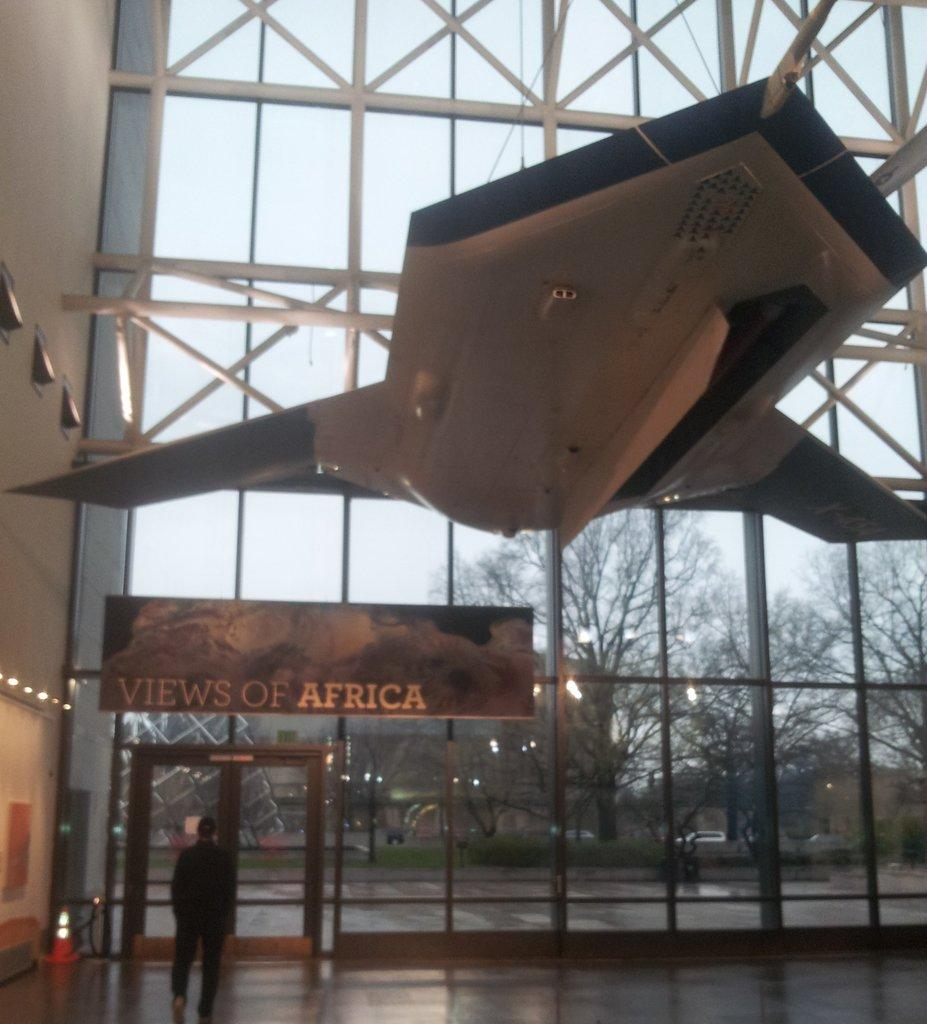<image>
Relay a brief, clear account of the picture shown. A building viewed from the inside with a banner "VIEWS OF AFRICA" suspended above the door. 